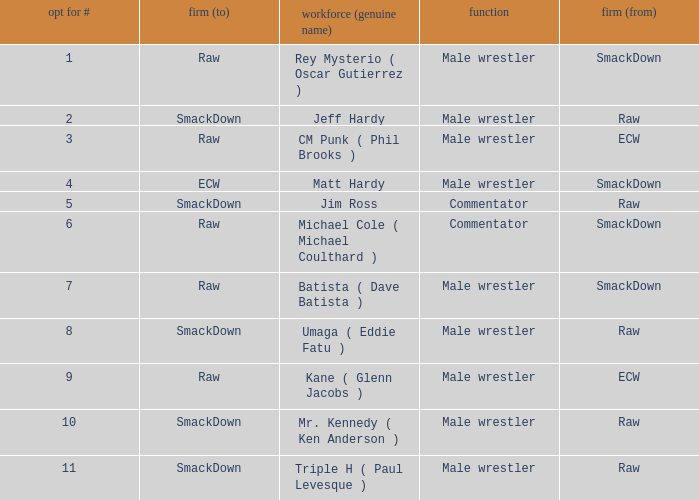Pick # 3 works for which brand? ECW. 